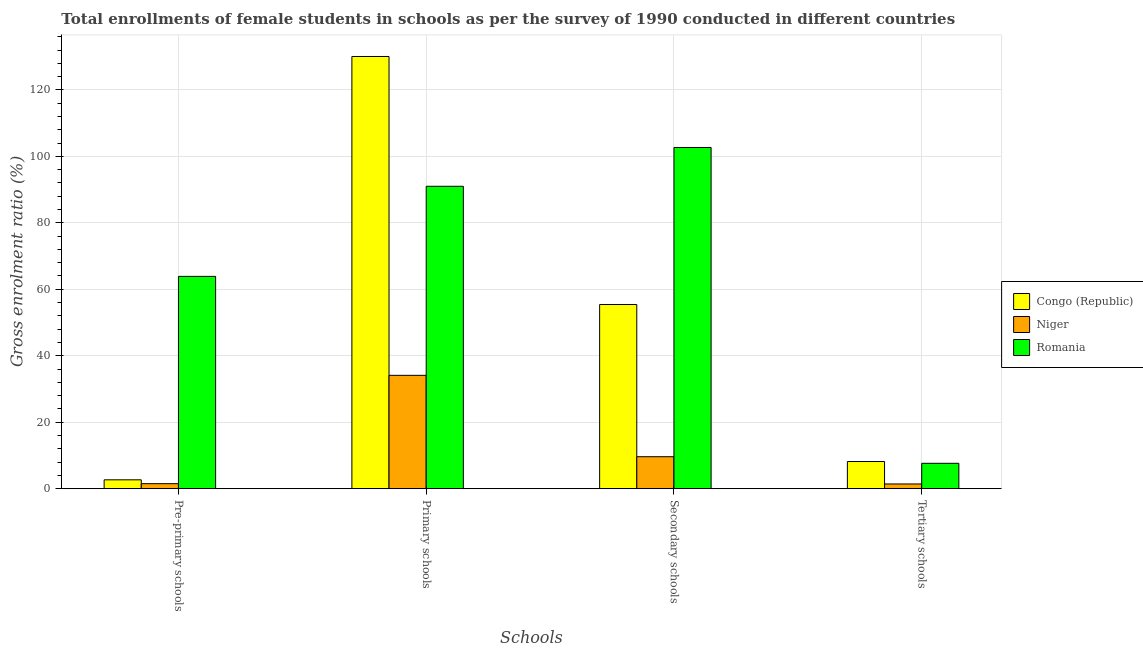How many different coloured bars are there?
Provide a succinct answer. 3. Are the number of bars per tick equal to the number of legend labels?
Your answer should be very brief. Yes. Are the number of bars on each tick of the X-axis equal?
Your answer should be compact. Yes. What is the label of the 4th group of bars from the left?
Your response must be concise. Tertiary schools. What is the gross enrolment ratio(female) in secondary schools in Congo (Republic)?
Make the answer very short. 55.42. Across all countries, what is the maximum gross enrolment ratio(female) in primary schools?
Offer a very short reply. 130.06. Across all countries, what is the minimum gross enrolment ratio(female) in secondary schools?
Ensure brevity in your answer.  9.62. In which country was the gross enrolment ratio(female) in tertiary schools maximum?
Give a very brief answer. Congo (Republic). In which country was the gross enrolment ratio(female) in secondary schools minimum?
Your response must be concise. Niger. What is the total gross enrolment ratio(female) in pre-primary schools in the graph?
Give a very brief answer. 68.05. What is the difference between the gross enrolment ratio(female) in secondary schools in Romania and that in Niger?
Offer a terse response. 93.06. What is the difference between the gross enrolment ratio(female) in secondary schools in Niger and the gross enrolment ratio(female) in pre-primary schools in Romania?
Your answer should be compact. -54.27. What is the average gross enrolment ratio(female) in secondary schools per country?
Offer a terse response. 55.9. What is the difference between the gross enrolment ratio(female) in secondary schools and gross enrolment ratio(female) in primary schools in Romania?
Your response must be concise. 11.68. In how many countries, is the gross enrolment ratio(female) in pre-primary schools greater than 20 %?
Your answer should be very brief. 1. What is the ratio of the gross enrolment ratio(female) in secondary schools in Romania to that in Congo (Republic)?
Provide a short and direct response. 1.85. Is the difference between the gross enrolment ratio(female) in primary schools in Niger and Congo (Republic) greater than the difference between the gross enrolment ratio(female) in secondary schools in Niger and Congo (Republic)?
Your answer should be compact. No. What is the difference between the highest and the second highest gross enrolment ratio(female) in primary schools?
Ensure brevity in your answer.  39.06. What is the difference between the highest and the lowest gross enrolment ratio(female) in secondary schools?
Offer a very short reply. 93.06. In how many countries, is the gross enrolment ratio(female) in pre-primary schools greater than the average gross enrolment ratio(female) in pre-primary schools taken over all countries?
Provide a short and direct response. 1. Is it the case that in every country, the sum of the gross enrolment ratio(female) in pre-primary schools and gross enrolment ratio(female) in primary schools is greater than the sum of gross enrolment ratio(female) in tertiary schools and gross enrolment ratio(female) in secondary schools?
Keep it short and to the point. No. What does the 2nd bar from the left in Pre-primary schools represents?
Make the answer very short. Niger. What does the 2nd bar from the right in Pre-primary schools represents?
Offer a terse response. Niger. How many bars are there?
Give a very brief answer. 12. Are all the bars in the graph horizontal?
Your response must be concise. No. How many countries are there in the graph?
Your response must be concise. 3. Are the values on the major ticks of Y-axis written in scientific E-notation?
Your answer should be compact. No. Does the graph contain grids?
Make the answer very short. Yes. Where does the legend appear in the graph?
Your answer should be very brief. Center right. What is the title of the graph?
Your answer should be very brief. Total enrollments of female students in schools as per the survey of 1990 conducted in different countries. What is the label or title of the X-axis?
Provide a short and direct response. Schools. What is the Gross enrolment ratio (%) in Congo (Republic) in Pre-primary schools?
Your answer should be compact. 2.67. What is the Gross enrolment ratio (%) of Niger in Pre-primary schools?
Provide a succinct answer. 1.5. What is the Gross enrolment ratio (%) of Romania in Pre-primary schools?
Provide a short and direct response. 63.89. What is the Gross enrolment ratio (%) of Congo (Republic) in Primary schools?
Your response must be concise. 130.06. What is the Gross enrolment ratio (%) of Niger in Primary schools?
Make the answer very short. 34.11. What is the Gross enrolment ratio (%) of Romania in Primary schools?
Make the answer very short. 91. What is the Gross enrolment ratio (%) of Congo (Republic) in Secondary schools?
Your answer should be very brief. 55.42. What is the Gross enrolment ratio (%) in Niger in Secondary schools?
Ensure brevity in your answer.  9.62. What is the Gross enrolment ratio (%) of Romania in Secondary schools?
Provide a succinct answer. 102.67. What is the Gross enrolment ratio (%) of Congo (Republic) in Tertiary schools?
Provide a succinct answer. 8.17. What is the Gross enrolment ratio (%) of Niger in Tertiary schools?
Your answer should be very brief. 1.42. What is the Gross enrolment ratio (%) of Romania in Tertiary schools?
Provide a succinct answer. 7.64. Across all Schools, what is the maximum Gross enrolment ratio (%) of Congo (Republic)?
Offer a very short reply. 130.06. Across all Schools, what is the maximum Gross enrolment ratio (%) of Niger?
Provide a succinct answer. 34.11. Across all Schools, what is the maximum Gross enrolment ratio (%) of Romania?
Make the answer very short. 102.67. Across all Schools, what is the minimum Gross enrolment ratio (%) of Congo (Republic)?
Your answer should be very brief. 2.67. Across all Schools, what is the minimum Gross enrolment ratio (%) in Niger?
Offer a very short reply. 1.42. Across all Schools, what is the minimum Gross enrolment ratio (%) in Romania?
Keep it short and to the point. 7.64. What is the total Gross enrolment ratio (%) of Congo (Republic) in the graph?
Your response must be concise. 196.31. What is the total Gross enrolment ratio (%) in Niger in the graph?
Your response must be concise. 46.64. What is the total Gross enrolment ratio (%) in Romania in the graph?
Provide a short and direct response. 265.19. What is the difference between the Gross enrolment ratio (%) in Congo (Republic) in Pre-primary schools and that in Primary schools?
Your answer should be compact. -127.39. What is the difference between the Gross enrolment ratio (%) of Niger in Pre-primary schools and that in Primary schools?
Keep it short and to the point. -32.6. What is the difference between the Gross enrolment ratio (%) in Romania in Pre-primary schools and that in Primary schools?
Offer a very short reply. -27.11. What is the difference between the Gross enrolment ratio (%) in Congo (Republic) in Pre-primary schools and that in Secondary schools?
Offer a very short reply. -52.75. What is the difference between the Gross enrolment ratio (%) in Niger in Pre-primary schools and that in Secondary schools?
Your response must be concise. -8.12. What is the difference between the Gross enrolment ratio (%) of Romania in Pre-primary schools and that in Secondary schools?
Provide a succinct answer. -38.79. What is the difference between the Gross enrolment ratio (%) in Congo (Republic) in Pre-primary schools and that in Tertiary schools?
Ensure brevity in your answer.  -5.5. What is the difference between the Gross enrolment ratio (%) in Niger in Pre-primary schools and that in Tertiary schools?
Keep it short and to the point. 0.08. What is the difference between the Gross enrolment ratio (%) of Romania in Pre-primary schools and that in Tertiary schools?
Your answer should be very brief. 56.25. What is the difference between the Gross enrolment ratio (%) in Congo (Republic) in Primary schools and that in Secondary schools?
Offer a terse response. 74.64. What is the difference between the Gross enrolment ratio (%) of Niger in Primary schools and that in Secondary schools?
Provide a succinct answer. 24.49. What is the difference between the Gross enrolment ratio (%) of Romania in Primary schools and that in Secondary schools?
Provide a succinct answer. -11.68. What is the difference between the Gross enrolment ratio (%) of Congo (Republic) in Primary schools and that in Tertiary schools?
Give a very brief answer. 121.89. What is the difference between the Gross enrolment ratio (%) of Niger in Primary schools and that in Tertiary schools?
Offer a terse response. 32.69. What is the difference between the Gross enrolment ratio (%) of Romania in Primary schools and that in Tertiary schools?
Provide a succinct answer. 83.36. What is the difference between the Gross enrolment ratio (%) in Congo (Republic) in Secondary schools and that in Tertiary schools?
Your answer should be compact. 47.25. What is the difference between the Gross enrolment ratio (%) of Niger in Secondary schools and that in Tertiary schools?
Offer a very short reply. 8.2. What is the difference between the Gross enrolment ratio (%) in Romania in Secondary schools and that in Tertiary schools?
Offer a terse response. 95.04. What is the difference between the Gross enrolment ratio (%) of Congo (Republic) in Pre-primary schools and the Gross enrolment ratio (%) of Niger in Primary schools?
Offer a terse response. -31.44. What is the difference between the Gross enrolment ratio (%) of Congo (Republic) in Pre-primary schools and the Gross enrolment ratio (%) of Romania in Primary schools?
Your response must be concise. -88.33. What is the difference between the Gross enrolment ratio (%) in Niger in Pre-primary schools and the Gross enrolment ratio (%) in Romania in Primary schools?
Offer a terse response. -89.49. What is the difference between the Gross enrolment ratio (%) of Congo (Republic) in Pre-primary schools and the Gross enrolment ratio (%) of Niger in Secondary schools?
Your answer should be compact. -6.95. What is the difference between the Gross enrolment ratio (%) of Congo (Republic) in Pre-primary schools and the Gross enrolment ratio (%) of Romania in Secondary schools?
Make the answer very short. -100.01. What is the difference between the Gross enrolment ratio (%) of Niger in Pre-primary schools and the Gross enrolment ratio (%) of Romania in Secondary schools?
Your answer should be very brief. -101.17. What is the difference between the Gross enrolment ratio (%) in Congo (Republic) in Pre-primary schools and the Gross enrolment ratio (%) in Niger in Tertiary schools?
Your answer should be very brief. 1.25. What is the difference between the Gross enrolment ratio (%) of Congo (Republic) in Pre-primary schools and the Gross enrolment ratio (%) of Romania in Tertiary schools?
Provide a short and direct response. -4.97. What is the difference between the Gross enrolment ratio (%) of Niger in Pre-primary schools and the Gross enrolment ratio (%) of Romania in Tertiary schools?
Keep it short and to the point. -6.13. What is the difference between the Gross enrolment ratio (%) in Congo (Republic) in Primary schools and the Gross enrolment ratio (%) in Niger in Secondary schools?
Give a very brief answer. 120.44. What is the difference between the Gross enrolment ratio (%) in Congo (Republic) in Primary schools and the Gross enrolment ratio (%) in Romania in Secondary schools?
Ensure brevity in your answer.  27.38. What is the difference between the Gross enrolment ratio (%) in Niger in Primary schools and the Gross enrolment ratio (%) in Romania in Secondary schools?
Provide a succinct answer. -68.57. What is the difference between the Gross enrolment ratio (%) in Congo (Republic) in Primary schools and the Gross enrolment ratio (%) in Niger in Tertiary schools?
Make the answer very short. 128.64. What is the difference between the Gross enrolment ratio (%) in Congo (Republic) in Primary schools and the Gross enrolment ratio (%) in Romania in Tertiary schools?
Give a very brief answer. 122.42. What is the difference between the Gross enrolment ratio (%) in Niger in Primary schools and the Gross enrolment ratio (%) in Romania in Tertiary schools?
Make the answer very short. 26.47. What is the difference between the Gross enrolment ratio (%) of Congo (Republic) in Secondary schools and the Gross enrolment ratio (%) of Niger in Tertiary schools?
Ensure brevity in your answer.  54. What is the difference between the Gross enrolment ratio (%) in Congo (Republic) in Secondary schools and the Gross enrolment ratio (%) in Romania in Tertiary schools?
Your answer should be very brief. 47.78. What is the difference between the Gross enrolment ratio (%) in Niger in Secondary schools and the Gross enrolment ratio (%) in Romania in Tertiary schools?
Your response must be concise. 1.98. What is the average Gross enrolment ratio (%) in Congo (Republic) per Schools?
Offer a very short reply. 49.08. What is the average Gross enrolment ratio (%) in Niger per Schools?
Your answer should be very brief. 11.66. What is the average Gross enrolment ratio (%) of Romania per Schools?
Your answer should be very brief. 66.3. What is the difference between the Gross enrolment ratio (%) of Congo (Republic) and Gross enrolment ratio (%) of Niger in Pre-primary schools?
Your response must be concise. 1.17. What is the difference between the Gross enrolment ratio (%) in Congo (Republic) and Gross enrolment ratio (%) in Romania in Pre-primary schools?
Provide a short and direct response. -61.22. What is the difference between the Gross enrolment ratio (%) of Niger and Gross enrolment ratio (%) of Romania in Pre-primary schools?
Give a very brief answer. -62.38. What is the difference between the Gross enrolment ratio (%) in Congo (Republic) and Gross enrolment ratio (%) in Niger in Primary schools?
Keep it short and to the point. 95.95. What is the difference between the Gross enrolment ratio (%) in Congo (Republic) and Gross enrolment ratio (%) in Romania in Primary schools?
Provide a succinct answer. 39.06. What is the difference between the Gross enrolment ratio (%) in Niger and Gross enrolment ratio (%) in Romania in Primary schools?
Provide a short and direct response. -56.89. What is the difference between the Gross enrolment ratio (%) in Congo (Republic) and Gross enrolment ratio (%) in Niger in Secondary schools?
Ensure brevity in your answer.  45.8. What is the difference between the Gross enrolment ratio (%) in Congo (Republic) and Gross enrolment ratio (%) in Romania in Secondary schools?
Keep it short and to the point. -47.26. What is the difference between the Gross enrolment ratio (%) of Niger and Gross enrolment ratio (%) of Romania in Secondary schools?
Make the answer very short. -93.06. What is the difference between the Gross enrolment ratio (%) in Congo (Republic) and Gross enrolment ratio (%) in Niger in Tertiary schools?
Provide a succinct answer. 6.75. What is the difference between the Gross enrolment ratio (%) in Congo (Republic) and Gross enrolment ratio (%) in Romania in Tertiary schools?
Offer a very short reply. 0.53. What is the difference between the Gross enrolment ratio (%) of Niger and Gross enrolment ratio (%) of Romania in Tertiary schools?
Offer a terse response. -6.22. What is the ratio of the Gross enrolment ratio (%) of Congo (Republic) in Pre-primary schools to that in Primary schools?
Make the answer very short. 0.02. What is the ratio of the Gross enrolment ratio (%) of Niger in Pre-primary schools to that in Primary schools?
Provide a succinct answer. 0.04. What is the ratio of the Gross enrolment ratio (%) in Romania in Pre-primary schools to that in Primary schools?
Keep it short and to the point. 0.7. What is the ratio of the Gross enrolment ratio (%) of Congo (Republic) in Pre-primary schools to that in Secondary schools?
Offer a terse response. 0.05. What is the ratio of the Gross enrolment ratio (%) in Niger in Pre-primary schools to that in Secondary schools?
Offer a terse response. 0.16. What is the ratio of the Gross enrolment ratio (%) in Romania in Pre-primary schools to that in Secondary schools?
Ensure brevity in your answer.  0.62. What is the ratio of the Gross enrolment ratio (%) of Congo (Republic) in Pre-primary schools to that in Tertiary schools?
Offer a very short reply. 0.33. What is the ratio of the Gross enrolment ratio (%) of Niger in Pre-primary schools to that in Tertiary schools?
Your answer should be compact. 1.06. What is the ratio of the Gross enrolment ratio (%) in Romania in Pre-primary schools to that in Tertiary schools?
Give a very brief answer. 8.37. What is the ratio of the Gross enrolment ratio (%) in Congo (Republic) in Primary schools to that in Secondary schools?
Give a very brief answer. 2.35. What is the ratio of the Gross enrolment ratio (%) in Niger in Primary schools to that in Secondary schools?
Your response must be concise. 3.55. What is the ratio of the Gross enrolment ratio (%) of Romania in Primary schools to that in Secondary schools?
Provide a short and direct response. 0.89. What is the ratio of the Gross enrolment ratio (%) in Congo (Republic) in Primary schools to that in Tertiary schools?
Provide a short and direct response. 15.92. What is the ratio of the Gross enrolment ratio (%) in Niger in Primary schools to that in Tertiary schools?
Offer a very short reply. 24.04. What is the ratio of the Gross enrolment ratio (%) in Romania in Primary schools to that in Tertiary schools?
Provide a succinct answer. 11.92. What is the ratio of the Gross enrolment ratio (%) in Congo (Republic) in Secondary schools to that in Tertiary schools?
Provide a short and direct response. 6.78. What is the ratio of the Gross enrolment ratio (%) of Niger in Secondary schools to that in Tertiary schools?
Your answer should be very brief. 6.78. What is the ratio of the Gross enrolment ratio (%) in Romania in Secondary schools to that in Tertiary schools?
Give a very brief answer. 13.45. What is the difference between the highest and the second highest Gross enrolment ratio (%) in Congo (Republic)?
Ensure brevity in your answer.  74.64. What is the difference between the highest and the second highest Gross enrolment ratio (%) of Niger?
Give a very brief answer. 24.49. What is the difference between the highest and the second highest Gross enrolment ratio (%) of Romania?
Your response must be concise. 11.68. What is the difference between the highest and the lowest Gross enrolment ratio (%) of Congo (Republic)?
Provide a succinct answer. 127.39. What is the difference between the highest and the lowest Gross enrolment ratio (%) in Niger?
Give a very brief answer. 32.69. What is the difference between the highest and the lowest Gross enrolment ratio (%) in Romania?
Your answer should be compact. 95.04. 